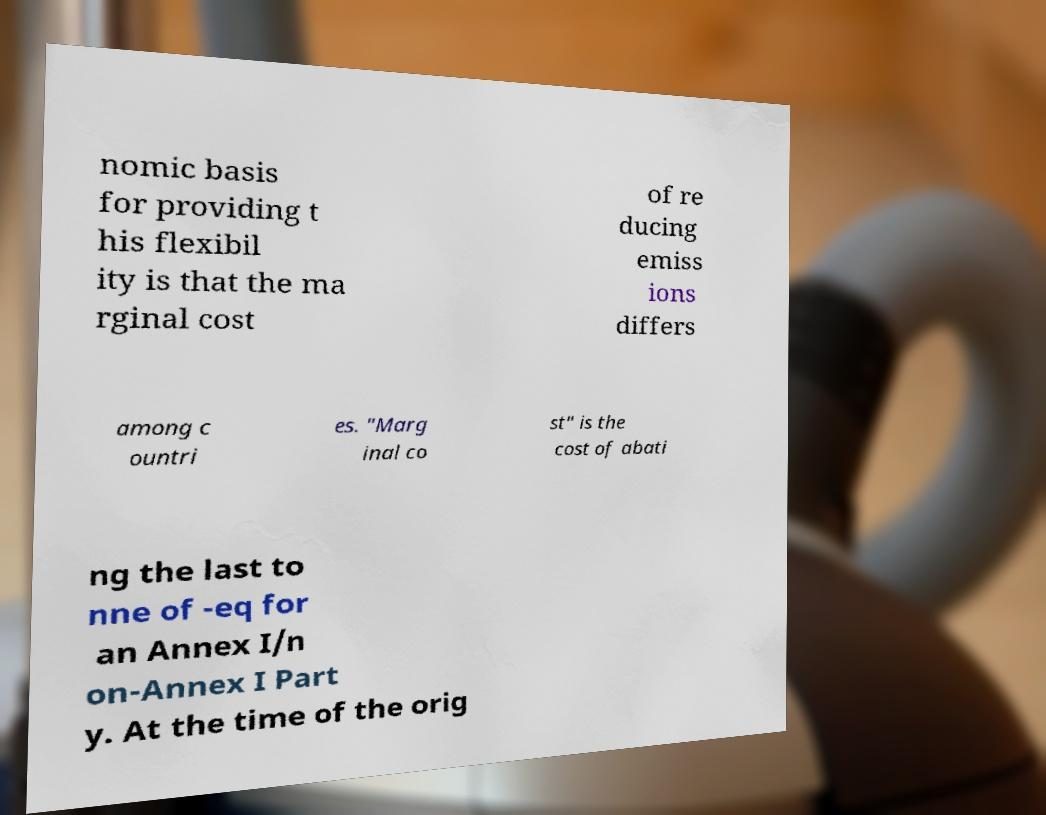Could you extract and type out the text from this image? nomic basis for providing t his flexibil ity is that the ma rginal cost of re ducing emiss ions differs among c ountri es. "Marg inal co st" is the cost of abati ng the last to nne of -eq for an Annex I/n on-Annex I Part y. At the time of the orig 